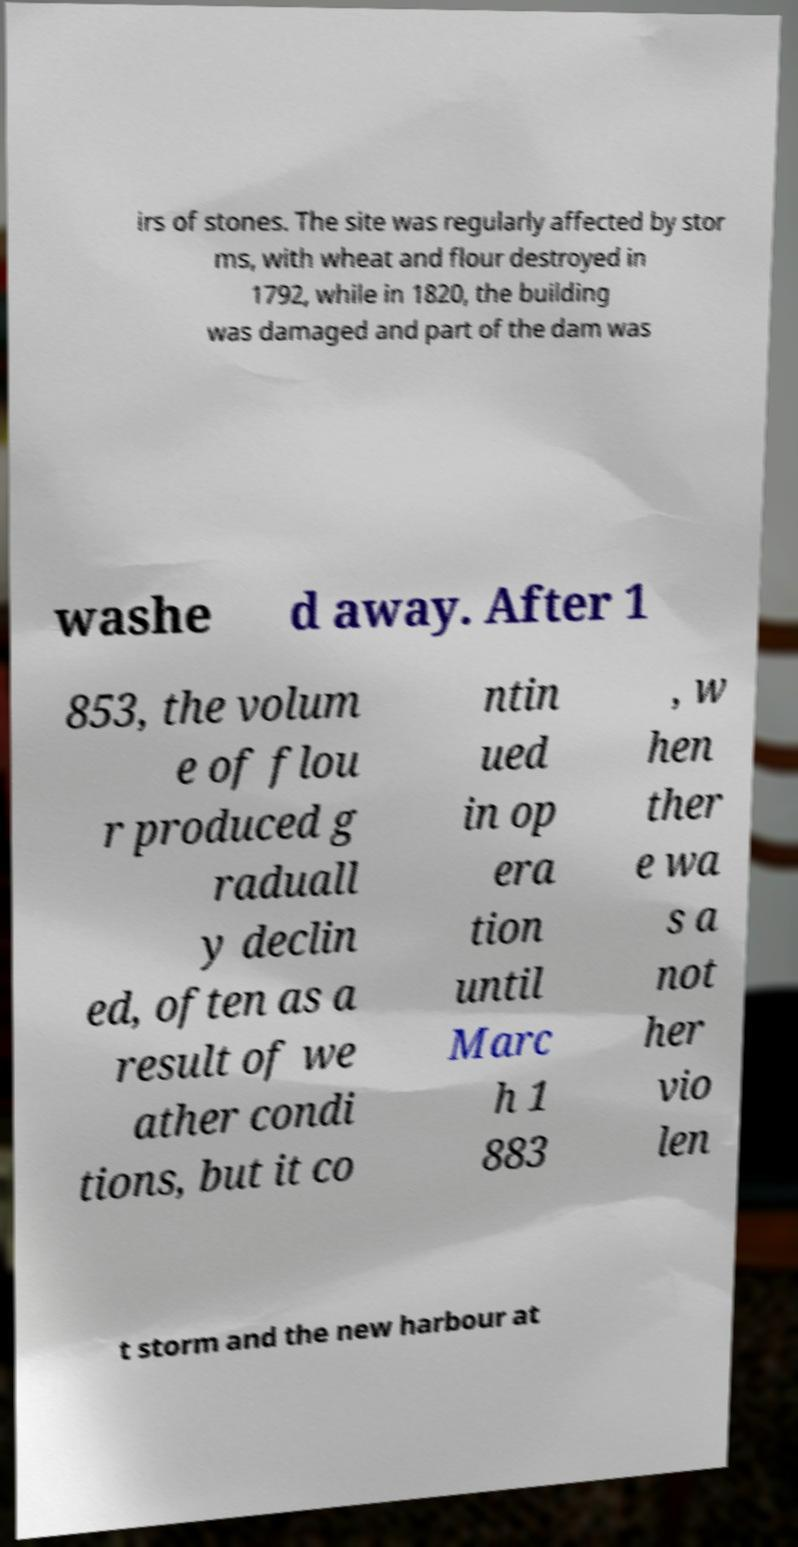Could you assist in decoding the text presented in this image and type it out clearly? irs of stones. The site was regularly affected by stor ms, with wheat and flour destroyed in 1792, while in 1820, the building was damaged and part of the dam was washe d away. After 1 853, the volum e of flou r produced g raduall y declin ed, often as a result of we ather condi tions, but it co ntin ued in op era tion until Marc h 1 883 , w hen ther e wa s a not her vio len t storm and the new harbour at 